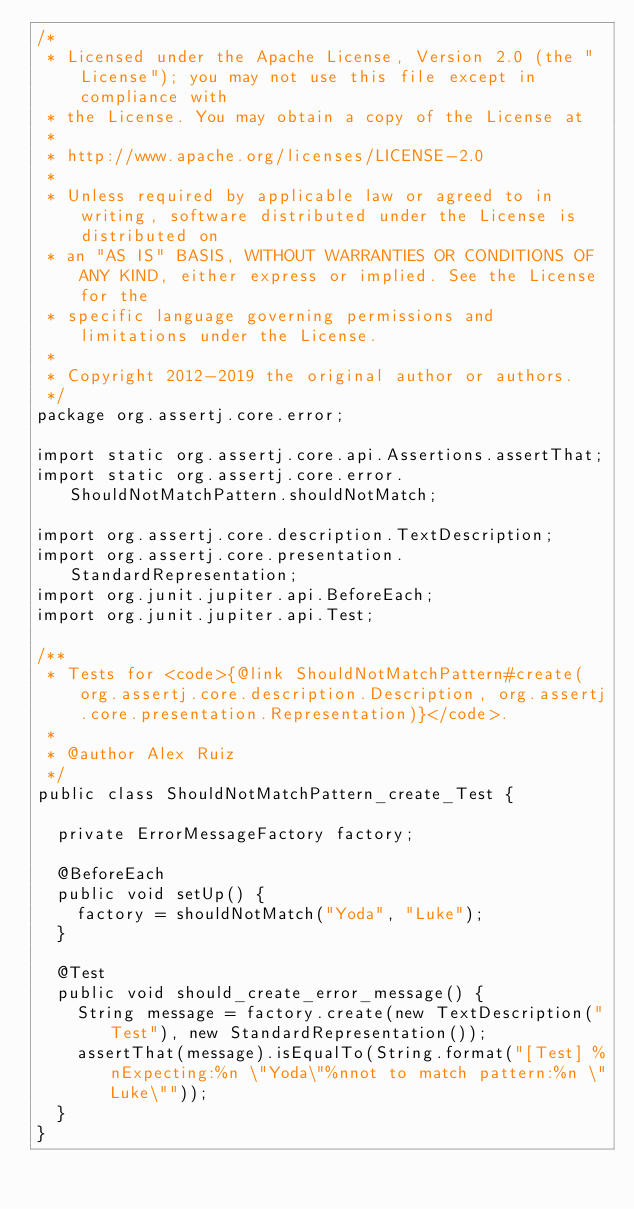Convert code to text. <code><loc_0><loc_0><loc_500><loc_500><_Java_>/*
 * Licensed under the Apache License, Version 2.0 (the "License"); you may not use this file except in compliance with
 * the License. You may obtain a copy of the License at
 *
 * http://www.apache.org/licenses/LICENSE-2.0
 *
 * Unless required by applicable law or agreed to in writing, software distributed under the License is distributed on
 * an "AS IS" BASIS, WITHOUT WARRANTIES OR CONDITIONS OF ANY KIND, either express or implied. See the License for the
 * specific language governing permissions and limitations under the License.
 *
 * Copyright 2012-2019 the original author or authors.
 */
package org.assertj.core.error;

import static org.assertj.core.api.Assertions.assertThat;
import static org.assertj.core.error.ShouldNotMatchPattern.shouldNotMatch;

import org.assertj.core.description.TextDescription;
import org.assertj.core.presentation.StandardRepresentation;
import org.junit.jupiter.api.BeforeEach;
import org.junit.jupiter.api.Test;

/**
 * Tests for <code>{@link ShouldNotMatchPattern#create(org.assertj.core.description.Description, org.assertj.core.presentation.Representation)}</code>.
 * 
 * @author Alex Ruiz
 */
public class ShouldNotMatchPattern_create_Test {

  private ErrorMessageFactory factory;

  @BeforeEach
  public void setUp() {
    factory = shouldNotMatch("Yoda", "Luke");
  }

  @Test
  public void should_create_error_message() {
    String message = factory.create(new TextDescription("Test"), new StandardRepresentation());
    assertThat(message).isEqualTo(String.format("[Test] %nExpecting:%n \"Yoda\"%nnot to match pattern:%n \"Luke\""));
  }
}
</code> 